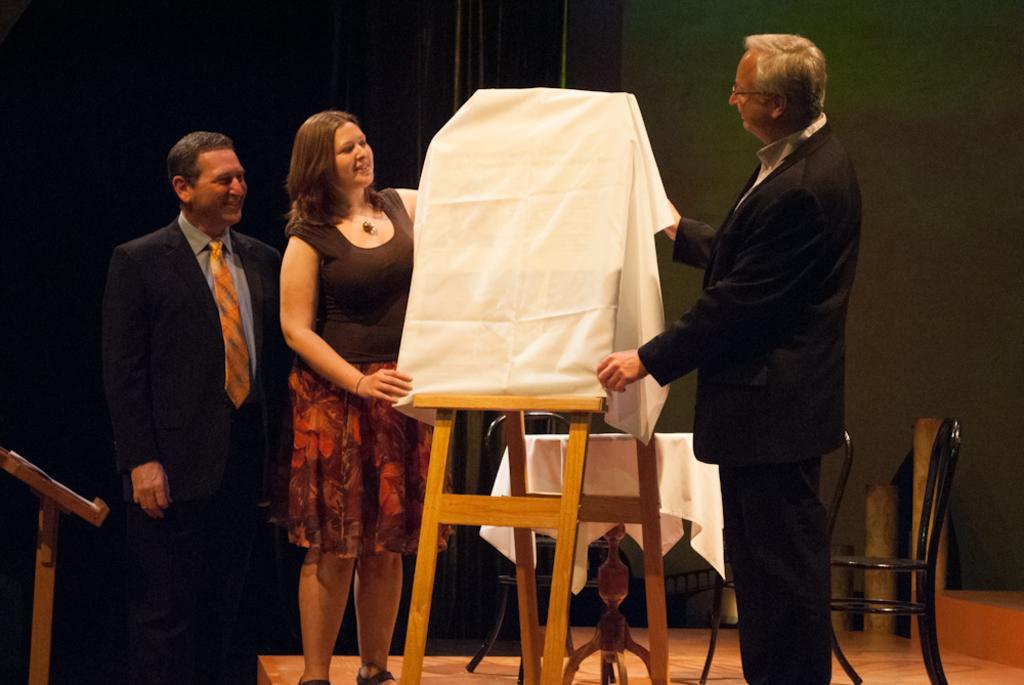Describe this image in one or two sentences. In this picture i can see two men and a woman are standing on the floor. The men are wearing black color suit and tie. In the middle of the image i can see an object is covered with white color cloth. In the background i can see table, chair and a wall. 